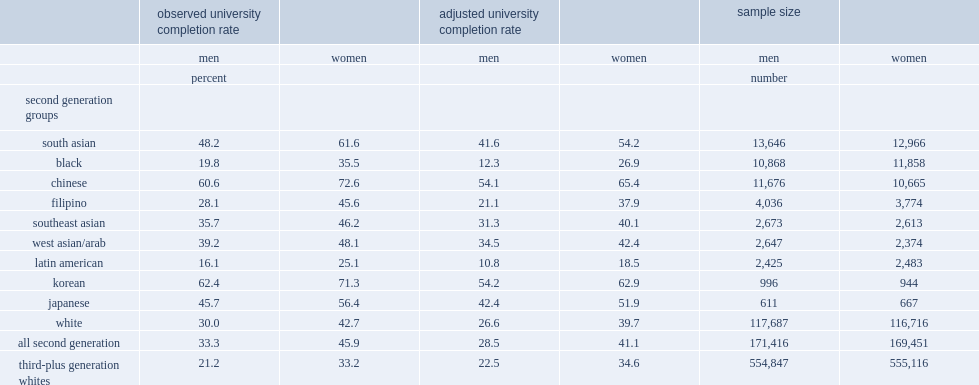Would you be able to parse every entry in this table? {'header': ['', 'observed university completion rate', '', 'adjusted university completion rate', '', 'sample size', ''], 'rows': [['', 'men', 'women', 'men', 'women', 'men', 'women'], ['', 'percent', '', '', '', 'number', ''], ['second generation groups', '', '', '', '', '', ''], ['south asian', '48.2', '61.6', '41.6', '54.2', '13,646', '12,966'], ['black', '19.8', '35.5', '12.3', '26.9', '10,868', '11,858'], ['chinese', '60.6', '72.6', '54.1', '65.4', '11,676', '10,665'], ['filipino', '28.1', '45.6', '21.1', '37.9', '4,036', '3,774'], ['southeast asian', '35.7', '46.2', '31.3', '40.1', '2,673', '2,613'], ['west asian/arab', '39.2', '48.1', '34.5', '42.4', '2,647', '2,374'], ['latin american', '16.1', '25.1', '10.8', '18.5', '2,425', '2,483'], ['korean', '62.4', '71.3', '54.2', '62.9', '996', '944'], ['japanese', '45.7', '56.4', '42.4', '51.9', '611', '667'], ['white', '30.0', '42.7', '26.6', '39.7', '117,687', '116,716'], ['all second generation', '33.3', '45.9', '28.5', '41.1', '171,416', '169,451'], ['third-plus generation whites', '21.2', '33.2', '22.5', '34.6', '554,847', '555,116']]} Which sex in second generation had higher university completion rates in all groups? Women. 